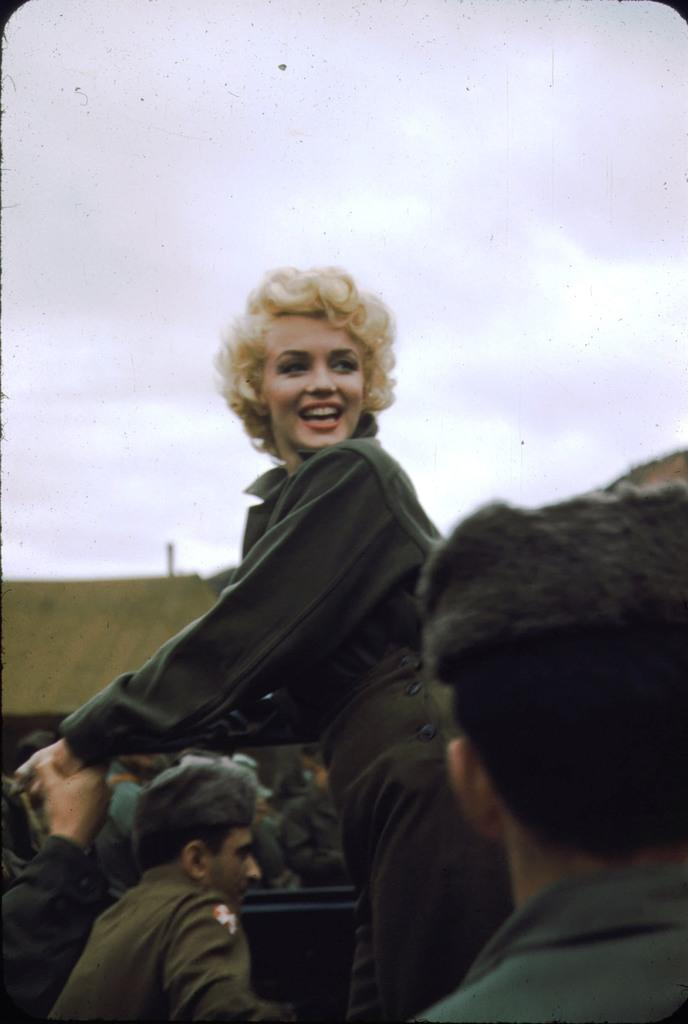What is the main subject of the image? The main subject of the image is a woman standing. Can you describe the surrounding environment in the image? Yes, there are people around the woman in the image. What type of animal can be seen interacting with the woman in the image? There is no animal present in the image, and therefore no such interaction can be observed. Can you recite a verse that is being spoken by the woman in the image? There is no indication in the image that the woman is speaking any verse, so it cannot be determined from the picture. 